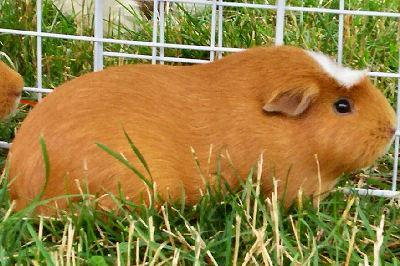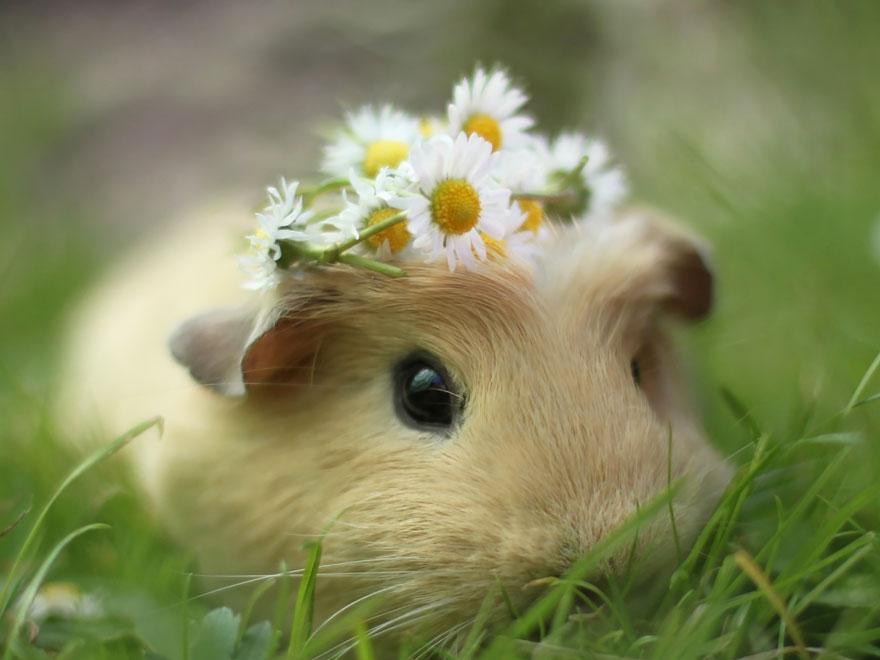The first image is the image on the left, the second image is the image on the right. Assess this claim about the two images: "One of the guinea pigs has patches of dark brown, black, and white fur.". Correct or not? Answer yes or no. No. 